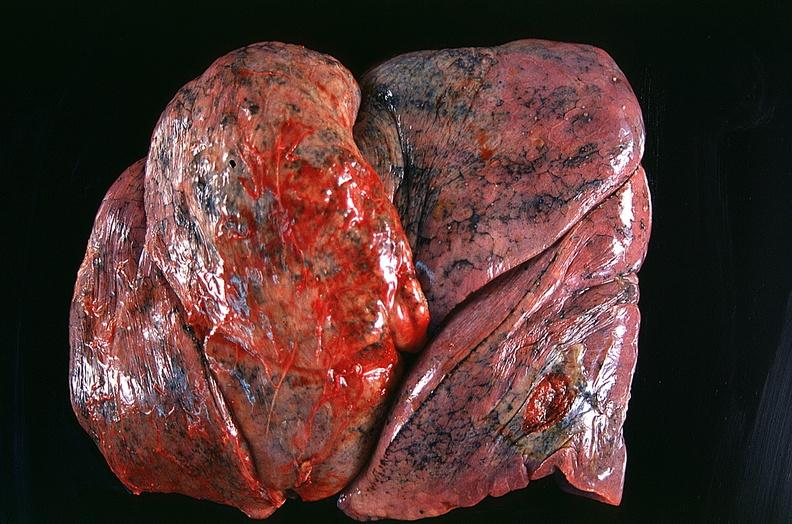what does this image show?
Answer the question using a single word or phrase. Lung 